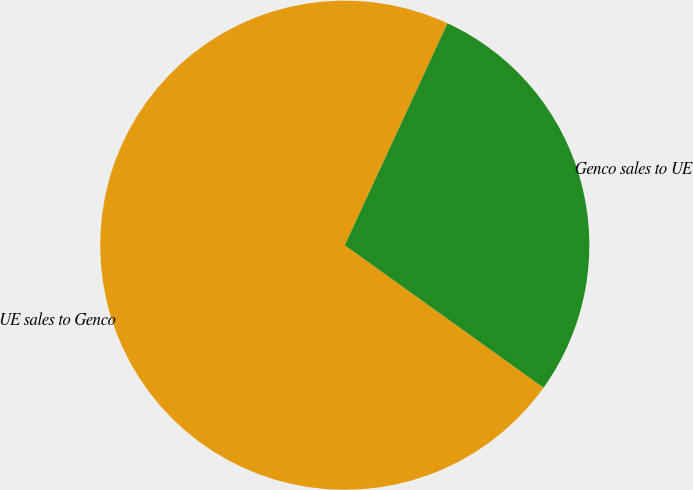<chart> <loc_0><loc_0><loc_500><loc_500><pie_chart><fcel>UE sales to Genco<fcel>Genco sales to UE<nl><fcel>72.0%<fcel>28.0%<nl></chart> 